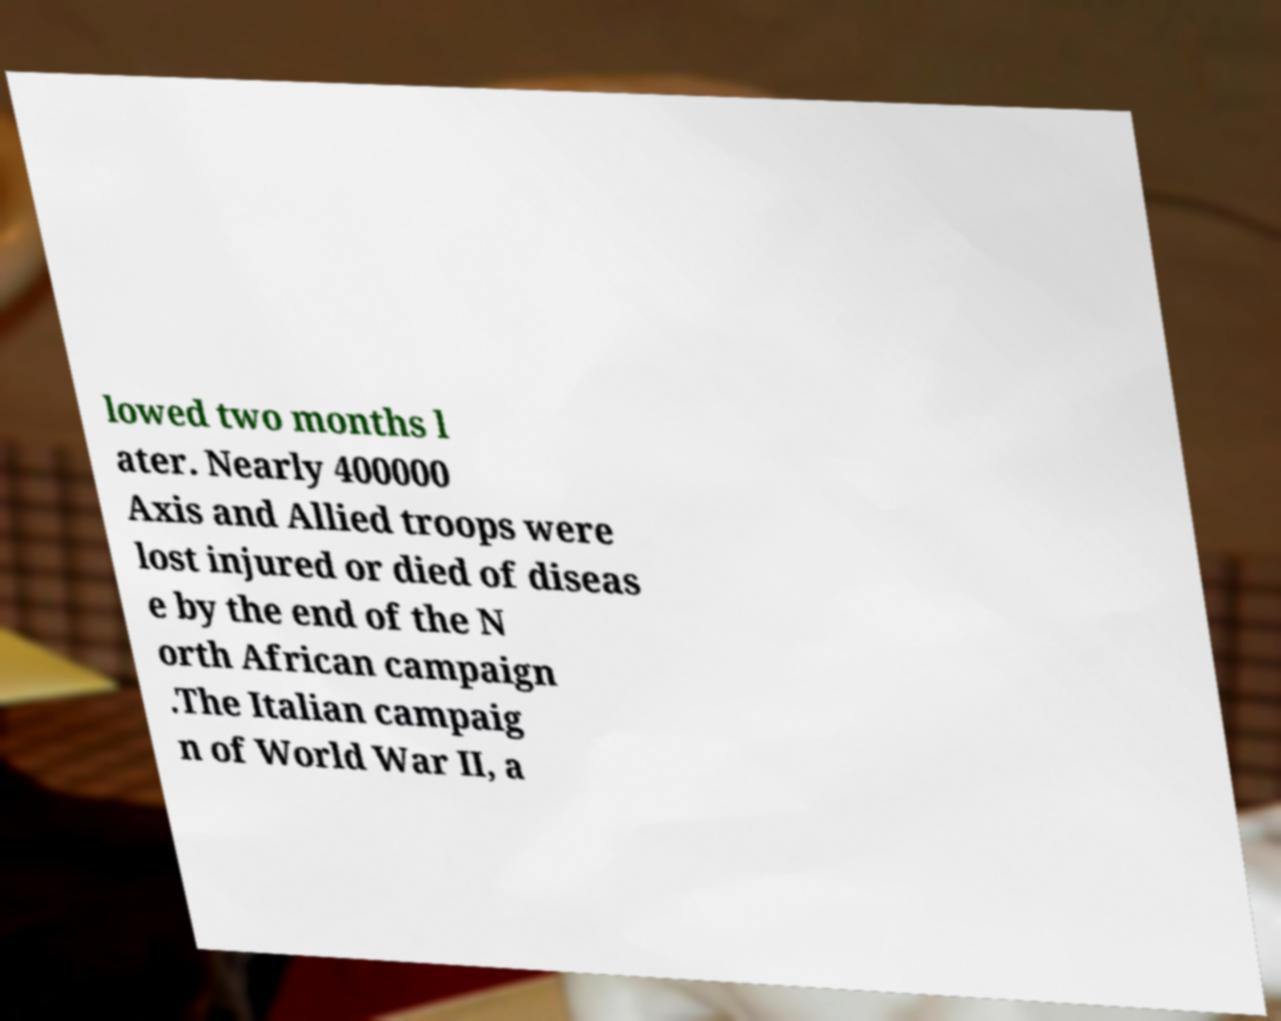There's text embedded in this image that I need extracted. Can you transcribe it verbatim? lowed two months l ater. Nearly 400000 Axis and Allied troops were lost injured or died of diseas e by the end of the N orth African campaign .The Italian campaig n of World War II, a 